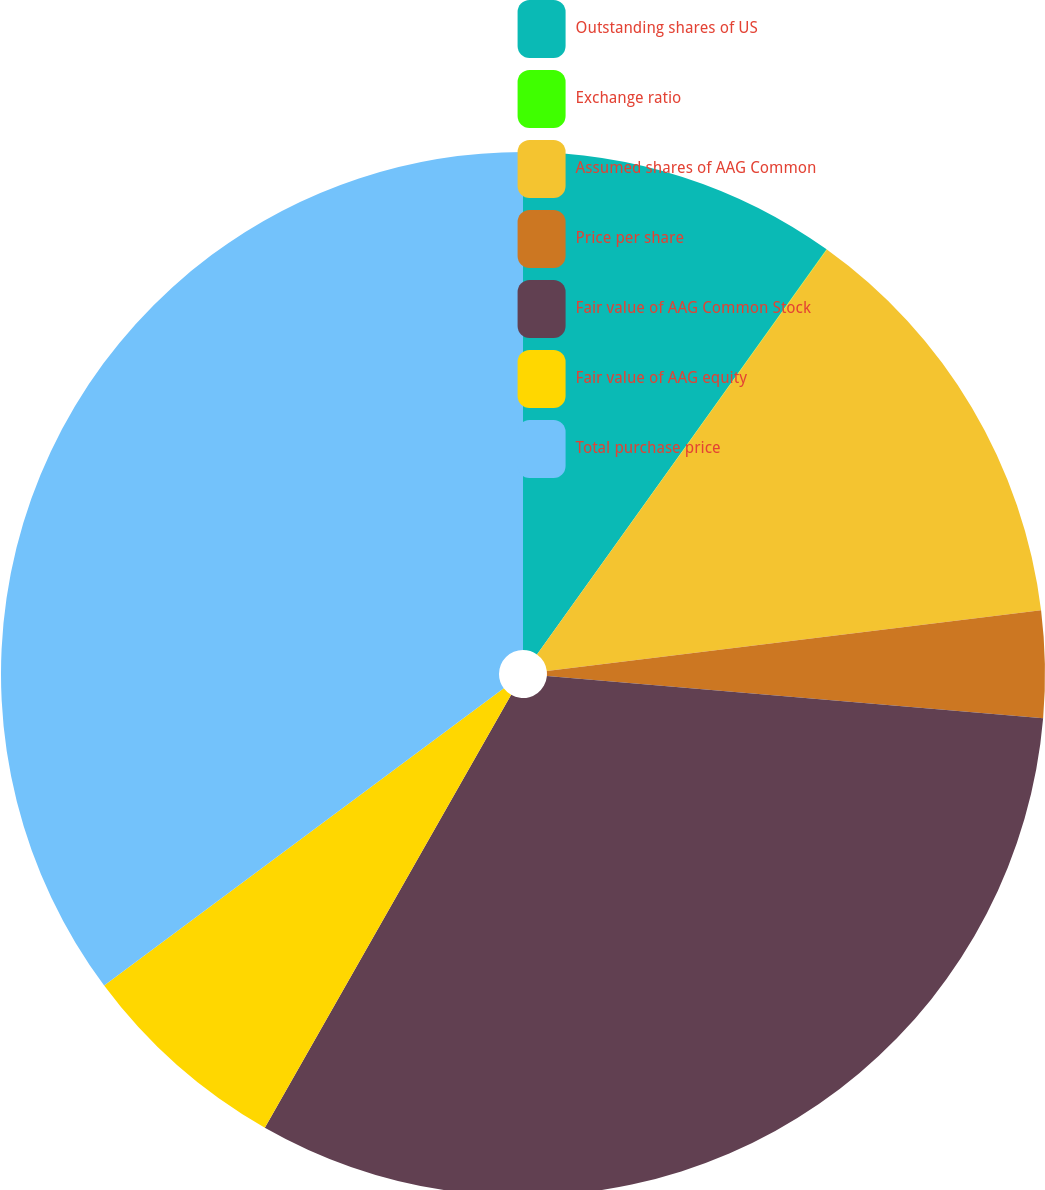Convert chart to OTSL. <chart><loc_0><loc_0><loc_500><loc_500><pie_chart><fcel>Outstanding shares of US<fcel>Exchange ratio<fcel>Assumed shares of AAG Common<fcel>Price per share<fcel>Fair value of AAG Common Stock<fcel>Fair value of AAG equity<fcel>Total purchase price<nl><fcel>9.88%<fcel>0.01%<fcel>13.16%<fcel>3.3%<fcel>31.89%<fcel>6.59%<fcel>35.18%<nl></chart> 